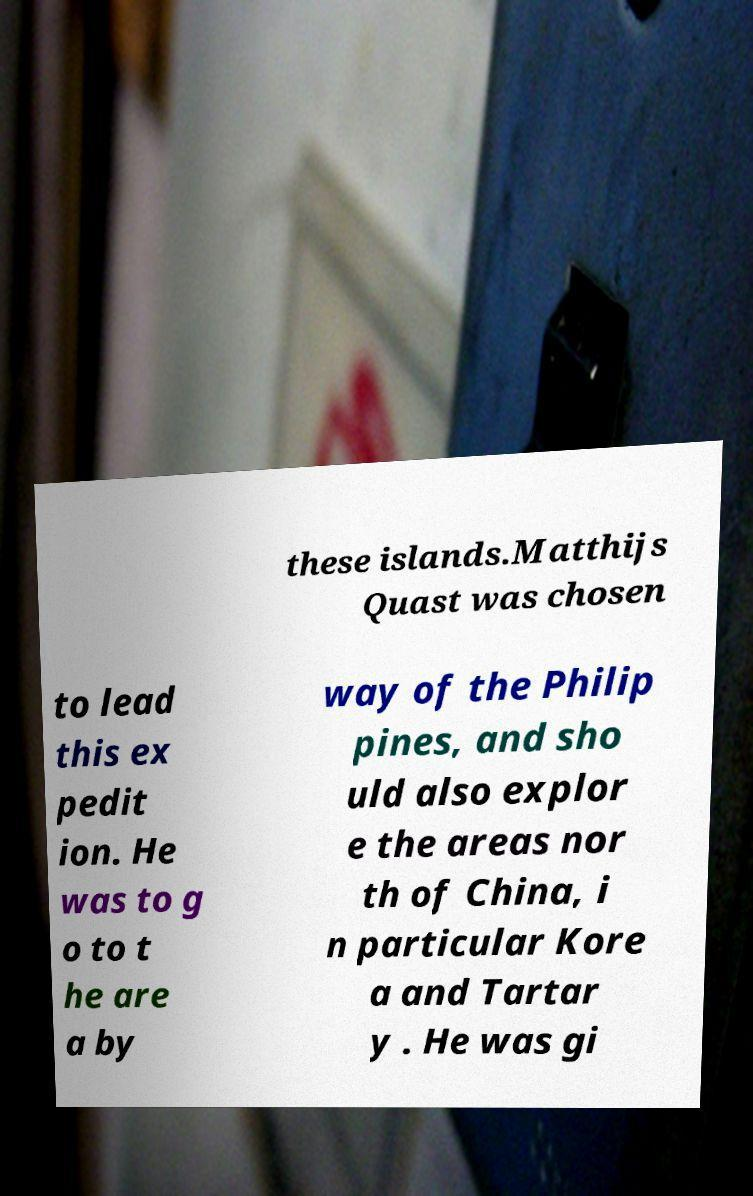Could you extract and type out the text from this image? these islands.Matthijs Quast was chosen to lead this ex pedit ion. He was to g o to t he are a by way of the Philip pines, and sho uld also explor e the areas nor th of China, i n particular Kore a and Tartar y . He was gi 